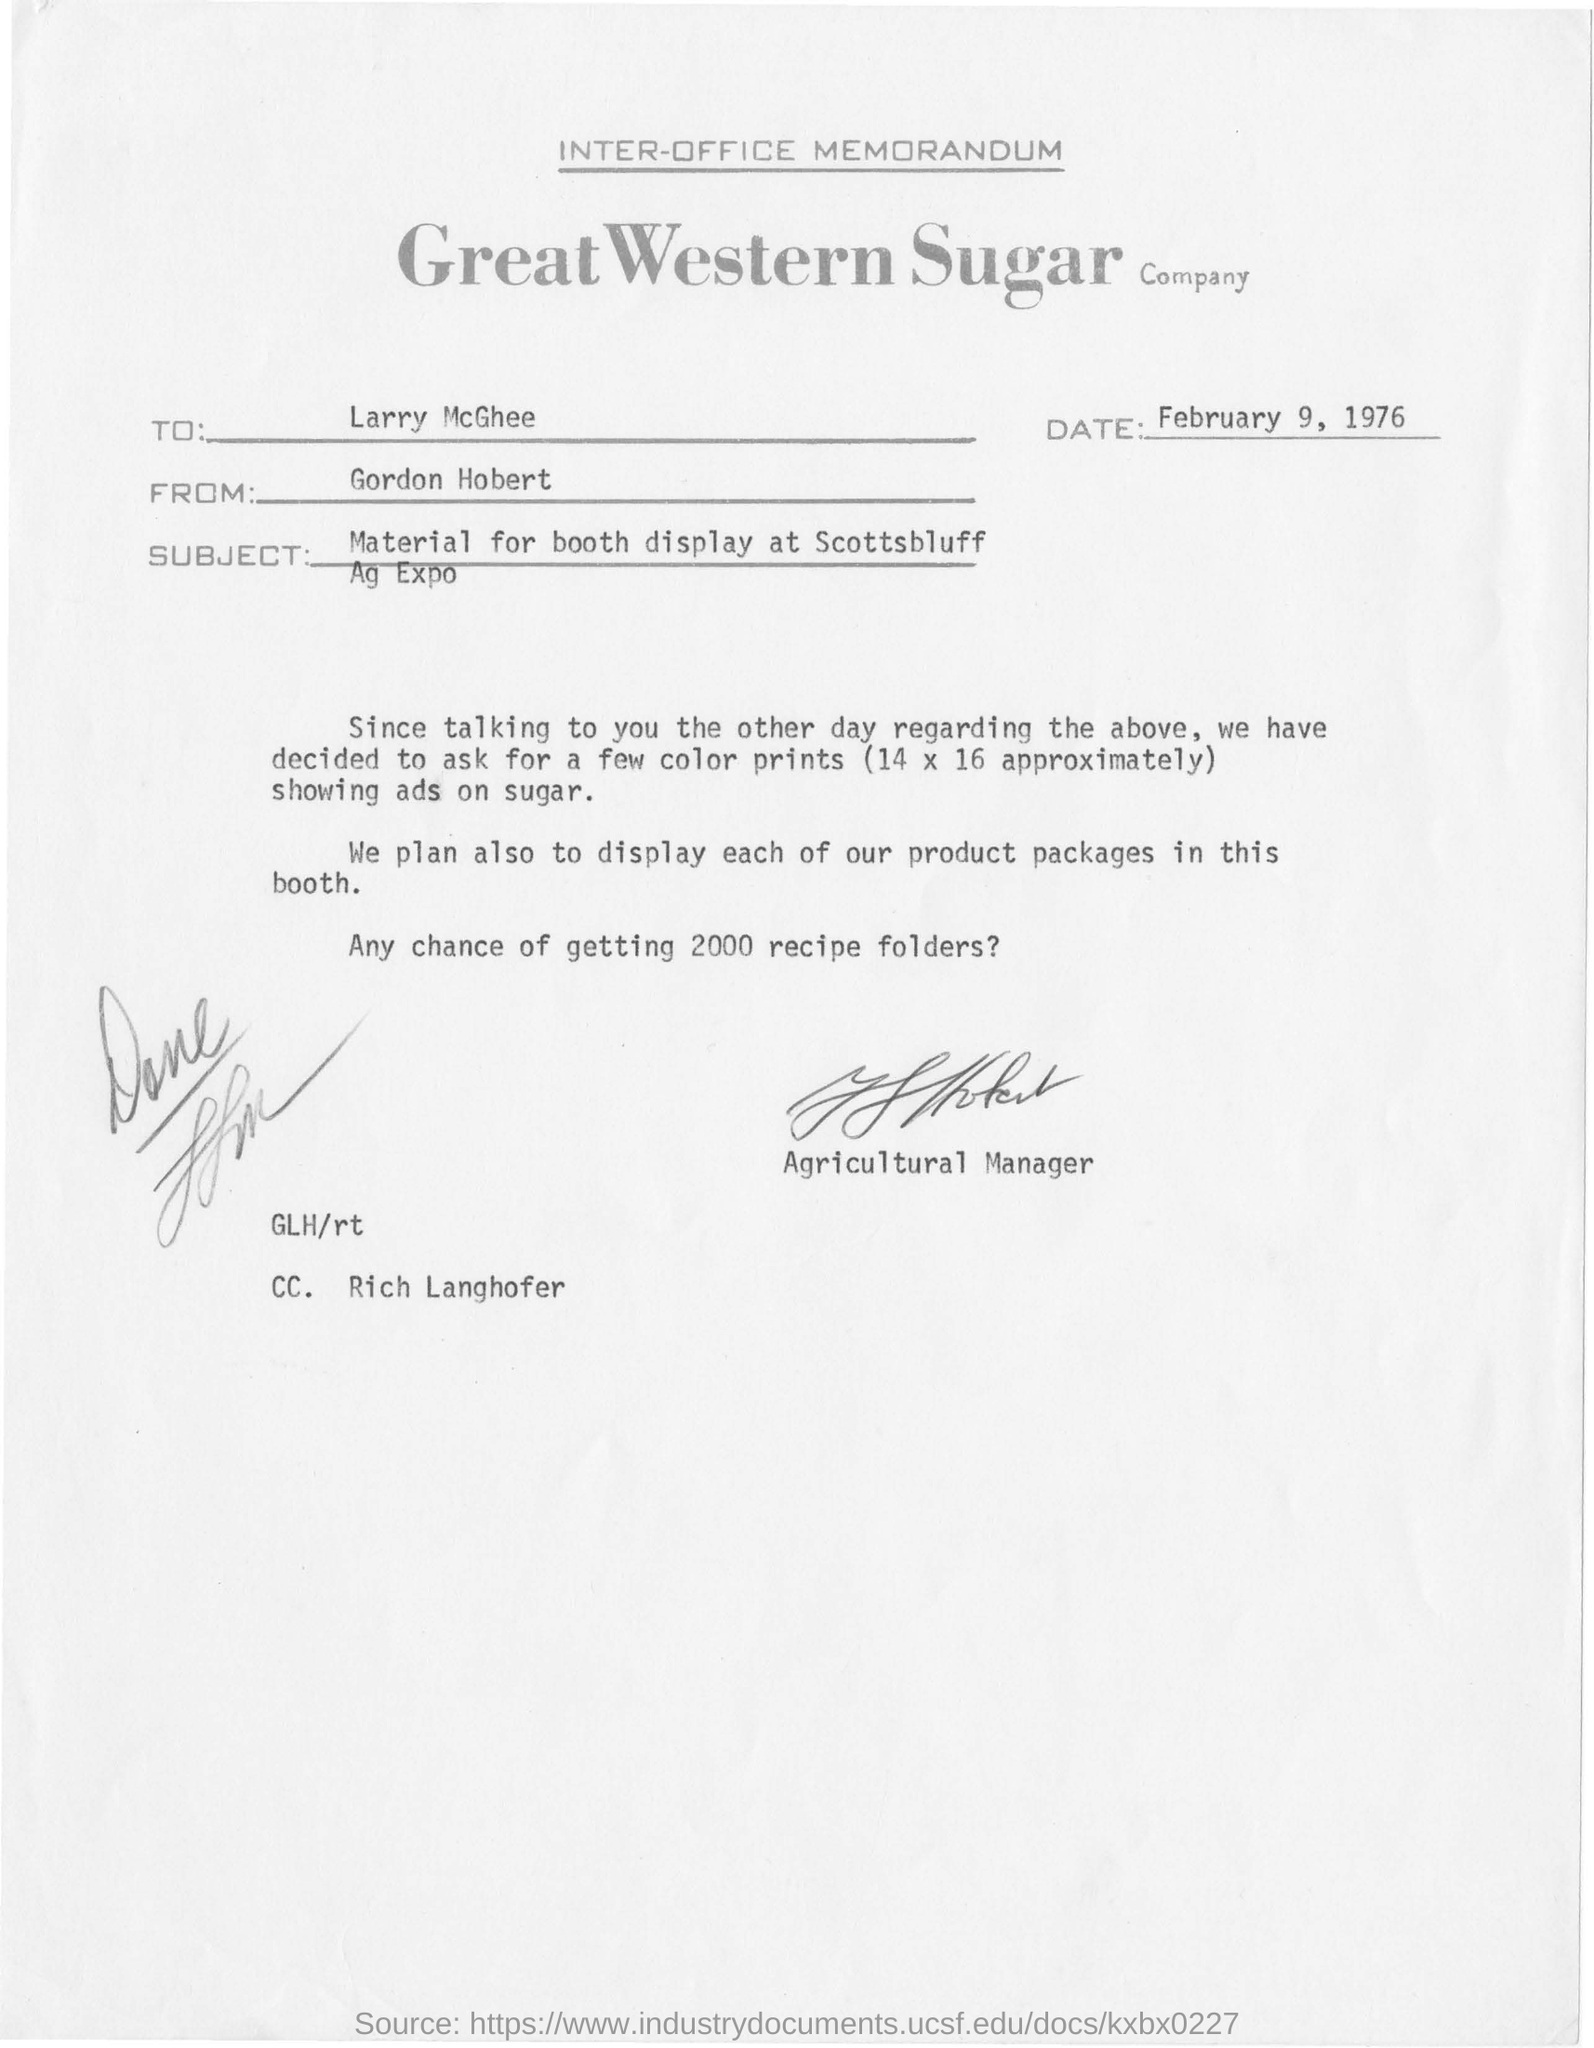Point out several critical features in this image. This memorandum is addressed to Larry McGhee. The memorandum is sent from Gordon Hobert. 